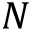<formula> <loc_0><loc_0><loc_500><loc_500>N</formula> 